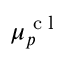Convert formula to latex. <formula><loc_0><loc_0><loc_500><loc_500>\mu _ { p } ^ { c l }</formula> 